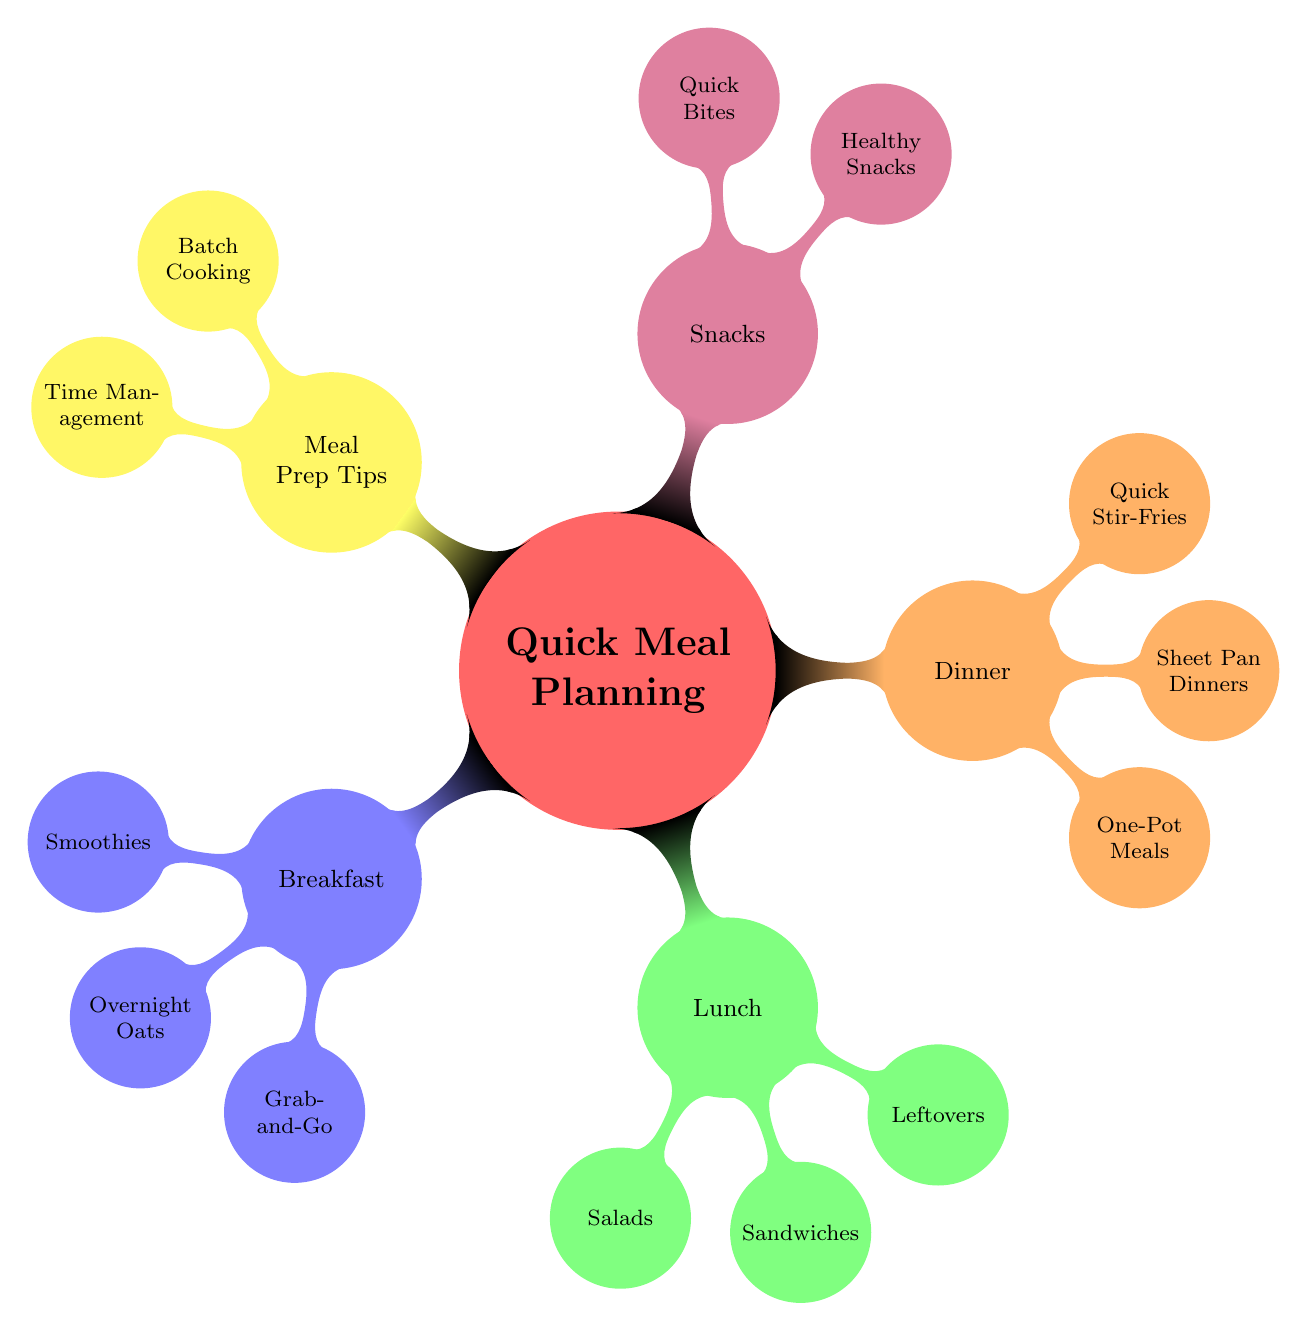What are the main meal categories in the diagram? The main meal categories listed in the diagram are Breakfast, Lunch, Dinner, Snacks, and Meal Prep Tips. These categories can be easily identified as the first-level children of the root node "Quick Meal Planning."
Answer: Breakfast, Lunch, Dinner, Snacks, Meal Prep Tips How many options are there for Breakfast? The Breakfast category has three options listed: Smoothies, Overnight Oats, and Grab-and-Go. Counting these directly reveals the total number of options under the Breakfast node.
Answer: 3 What type of meals are included under Dinner? The Dinner category includes One-Pot Meals, Sheet Pan Dinners, and Quick Stir-Fries as its types of meals. These are the children nodes branching out from Dinner.
Answer: One-Pot Meals, Sheet Pan Dinners, Quick Stir-Fries Which meal category includes "Chicken Caesar Salad"? The "Chicken Caesar Salad" is found under the Lunch category, specifically under the Salads child node. You can identify the relationship by tracing the path from Lunch to Salads.
Answer: Lunch What are the batch cooking tips mentioned in the Meal Prep Tips section? In the Meal Prep Tips section, the batch cooking tips mentioned are "Cook Rice in Bulk" and "Prepare Veggies Ahead." These tips are specific items listed under the Batch Cooking child node.
Answer: Cook Rice in Bulk, Prepare Veggies Ahead How many snacks are categorized as Healthy Snacks? In the Snacks category, two options are classified as Healthy Snacks: "Almonds" and "Fruit Mix." By counting these, you can determine the number of options under that specific node.
Answer: 2 Which meal option is categorized as a "Grab-and-Go" item? "Greek Yogurt" and "Granola Bars" are both classified as Grab-and-Go items under the Breakfast category. They are specific items listed beneath their parent node.
Answer: Greek Yogurt, Granola Bars How does the One-Pot Meals type relate to Dinner? One-Pot Meals is a specific type of meal categorized under Dinner. This relationship is established by understanding that One-Pot Meals is a child node directly connected to the Dinner parent node in the mind map.
Answer: Dinner 